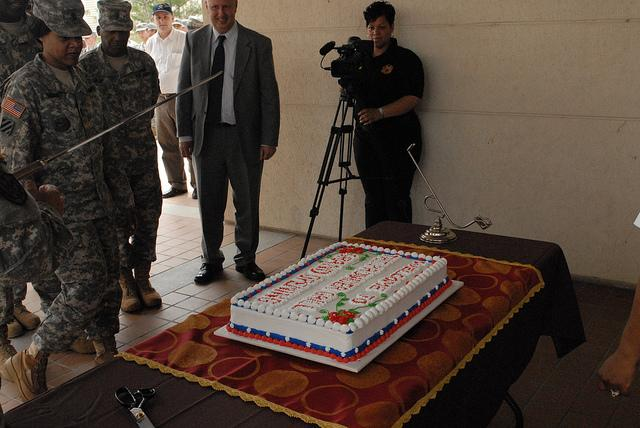What message does this cake send to those that see it?

Choices:
A) happy birthday
B) welcome
C) happy holiday
D) none welcome 